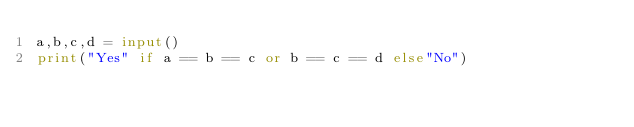<code> <loc_0><loc_0><loc_500><loc_500><_Python_>a,b,c,d = input()
print("Yes" if a == b == c or b == c == d else"No")</code> 